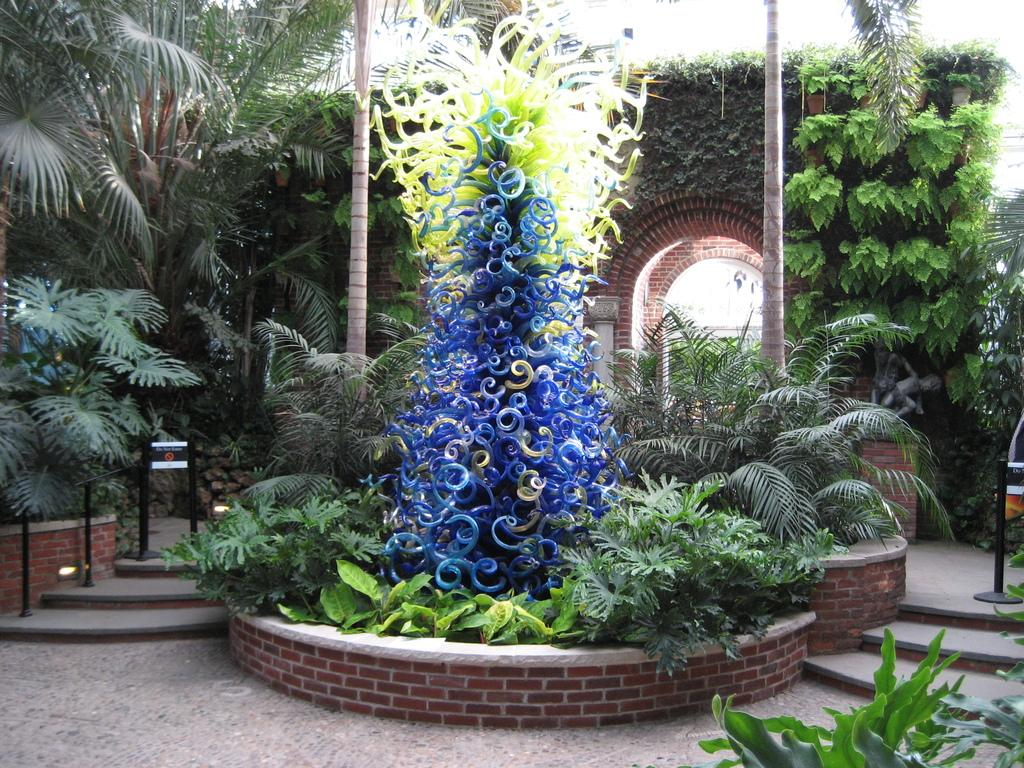What type of vegetation can be seen in the image? There are plants and trees in the image. Can you describe the plants and trees in the image? The image shows plants and trees, but specific details about their appearance cannot be determined from the provided facts. How many legs can be seen on the cream in the image? There is no cream present in the image, and therefore no legs can be observed. 